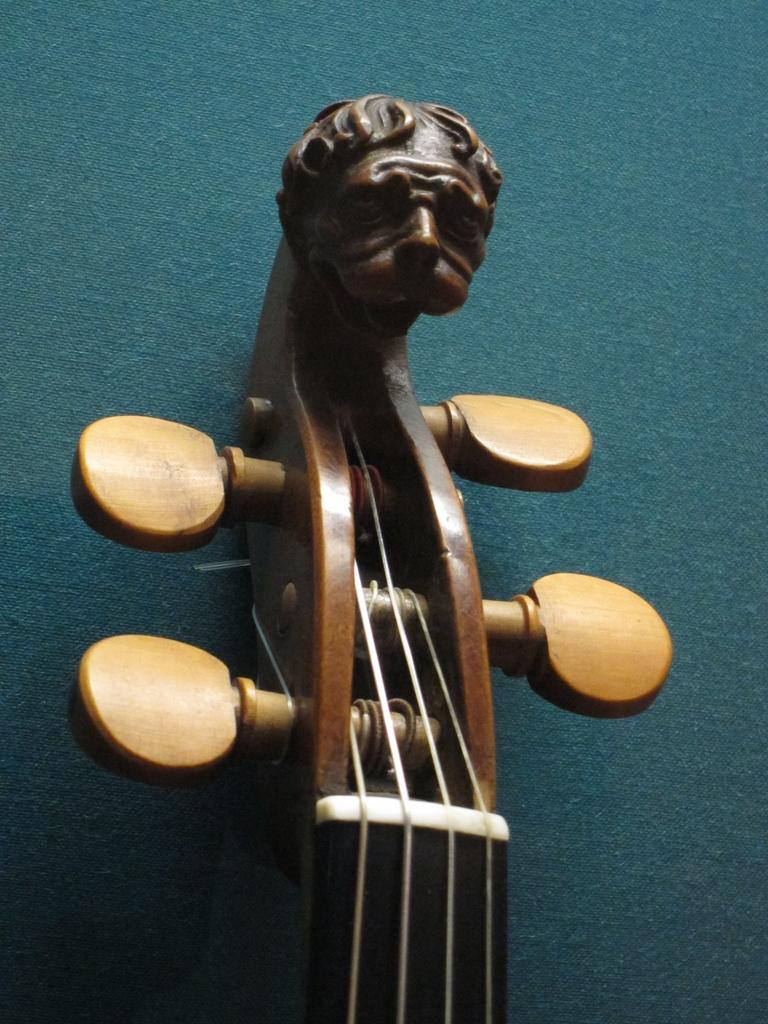What objects are present in the image? There are musical instruments in the image. What color is the background of the image? The background of the image is blue. What color are the musical instruments? The musical instruments are brown. What type of jam is being spread on the shirt in the image? There is no shirt or jam present in the image; it only features musical instruments and a blue background. 